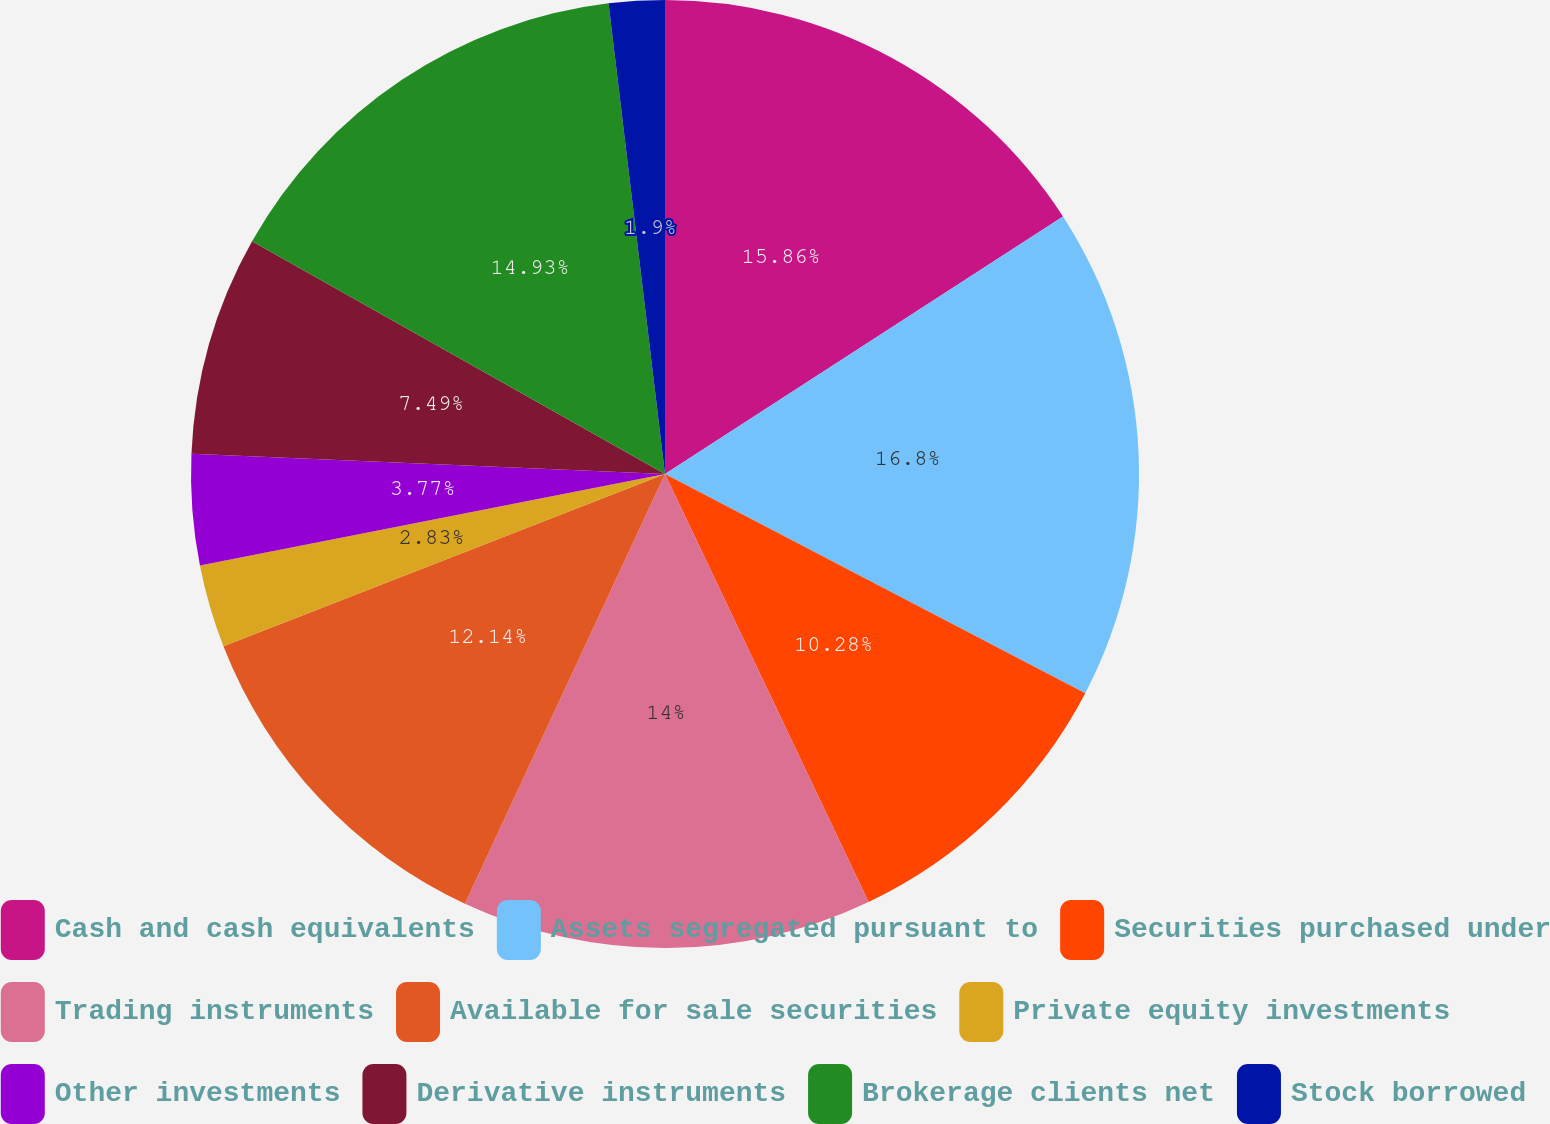Convert chart. <chart><loc_0><loc_0><loc_500><loc_500><pie_chart><fcel>Cash and cash equivalents<fcel>Assets segregated pursuant to<fcel>Securities purchased under<fcel>Trading instruments<fcel>Available for sale securities<fcel>Private equity investments<fcel>Other investments<fcel>Derivative instruments<fcel>Brokerage clients net<fcel>Stock borrowed<nl><fcel>15.86%<fcel>16.79%<fcel>10.28%<fcel>14.0%<fcel>12.14%<fcel>2.83%<fcel>3.77%<fcel>7.49%<fcel>14.93%<fcel>1.9%<nl></chart> 